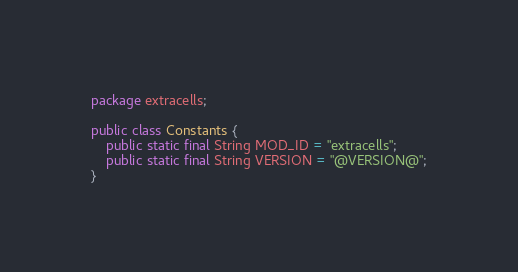Convert code to text. <code><loc_0><loc_0><loc_500><loc_500><_Java_>package extracells;

public class Constants {
	public static final String MOD_ID = "extracells";
	public static final String VERSION = "@VERSION@";
}
</code> 